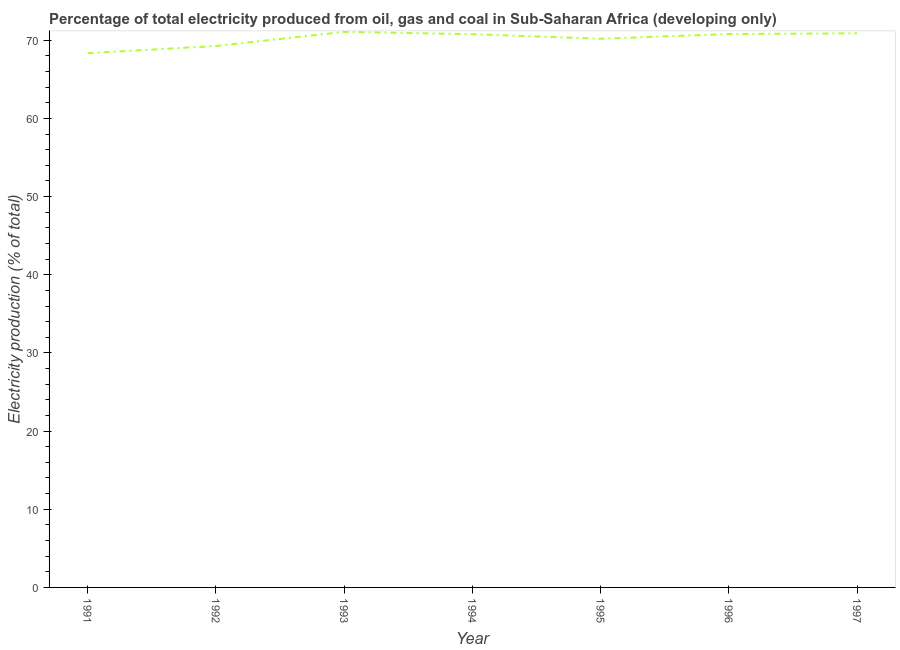What is the electricity production in 1995?
Offer a very short reply. 70.19. Across all years, what is the maximum electricity production?
Offer a very short reply. 71.07. Across all years, what is the minimum electricity production?
Make the answer very short. 68.35. In which year was the electricity production minimum?
Your answer should be very brief. 1991. What is the sum of the electricity production?
Your answer should be compact. 491.33. What is the difference between the electricity production in 1993 and 1997?
Provide a succinct answer. 0.18. What is the average electricity production per year?
Your answer should be very brief. 70.19. What is the median electricity production?
Make the answer very short. 70.78. In how many years, is the electricity production greater than 4 %?
Provide a short and direct response. 7. What is the ratio of the electricity production in 1991 to that in 1997?
Offer a terse response. 0.96. What is the difference between the highest and the second highest electricity production?
Provide a short and direct response. 0.18. Is the sum of the electricity production in 1996 and 1997 greater than the maximum electricity production across all years?
Provide a short and direct response. Yes. What is the difference between the highest and the lowest electricity production?
Provide a succinct answer. 2.72. Does the electricity production monotonically increase over the years?
Your answer should be very brief. No. Are the values on the major ticks of Y-axis written in scientific E-notation?
Offer a very short reply. No. What is the title of the graph?
Offer a very short reply. Percentage of total electricity produced from oil, gas and coal in Sub-Saharan Africa (developing only). What is the label or title of the Y-axis?
Give a very brief answer. Electricity production (% of total). What is the Electricity production (% of total) in 1991?
Your answer should be compact. 68.35. What is the Electricity production (% of total) of 1992?
Provide a short and direct response. 69.26. What is the Electricity production (% of total) of 1993?
Your answer should be very brief. 71.07. What is the Electricity production (% of total) in 1994?
Provide a succinct answer. 70.78. What is the Electricity production (% of total) in 1995?
Your response must be concise. 70.19. What is the Electricity production (% of total) in 1996?
Your response must be concise. 70.79. What is the Electricity production (% of total) in 1997?
Your answer should be compact. 70.89. What is the difference between the Electricity production (% of total) in 1991 and 1992?
Provide a succinct answer. -0.92. What is the difference between the Electricity production (% of total) in 1991 and 1993?
Give a very brief answer. -2.72. What is the difference between the Electricity production (% of total) in 1991 and 1994?
Your response must be concise. -2.43. What is the difference between the Electricity production (% of total) in 1991 and 1995?
Your answer should be very brief. -1.84. What is the difference between the Electricity production (% of total) in 1991 and 1996?
Ensure brevity in your answer.  -2.45. What is the difference between the Electricity production (% of total) in 1991 and 1997?
Offer a very short reply. -2.54. What is the difference between the Electricity production (% of total) in 1992 and 1993?
Your answer should be very brief. -1.8. What is the difference between the Electricity production (% of total) in 1992 and 1994?
Provide a short and direct response. -1.51. What is the difference between the Electricity production (% of total) in 1992 and 1995?
Offer a terse response. -0.93. What is the difference between the Electricity production (% of total) in 1992 and 1996?
Provide a succinct answer. -1.53. What is the difference between the Electricity production (% of total) in 1992 and 1997?
Offer a terse response. -1.63. What is the difference between the Electricity production (% of total) in 1993 and 1994?
Keep it short and to the point. 0.29. What is the difference between the Electricity production (% of total) in 1993 and 1995?
Offer a terse response. 0.88. What is the difference between the Electricity production (% of total) in 1993 and 1996?
Provide a short and direct response. 0.27. What is the difference between the Electricity production (% of total) in 1993 and 1997?
Provide a short and direct response. 0.18. What is the difference between the Electricity production (% of total) in 1994 and 1995?
Your response must be concise. 0.59. What is the difference between the Electricity production (% of total) in 1994 and 1996?
Make the answer very short. -0.02. What is the difference between the Electricity production (% of total) in 1994 and 1997?
Provide a succinct answer. -0.11. What is the difference between the Electricity production (% of total) in 1995 and 1996?
Your answer should be compact. -0.6. What is the difference between the Electricity production (% of total) in 1995 and 1997?
Offer a very short reply. -0.7. What is the difference between the Electricity production (% of total) in 1996 and 1997?
Your response must be concise. -0.09. What is the ratio of the Electricity production (% of total) in 1991 to that in 1992?
Give a very brief answer. 0.99. What is the ratio of the Electricity production (% of total) in 1991 to that in 1996?
Your answer should be very brief. 0.96. What is the ratio of the Electricity production (% of total) in 1992 to that in 1993?
Your answer should be very brief. 0.97. What is the ratio of the Electricity production (% of total) in 1992 to that in 1994?
Your response must be concise. 0.98. What is the ratio of the Electricity production (% of total) in 1993 to that in 1996?
Make the answer very short. 1. What is the ratio of the Electricity production (% of total) in 1994 to that in 1995?
Your answer should be compact. 1.01. What is the ratio of the Electricity production (% of total) in 1994 to that in 1997?
Provide a succinct answer. 1. What is the ratio of the Electricity production (% of total) in 1996 to that in 1997?
Keep it short and to the point. 1. 